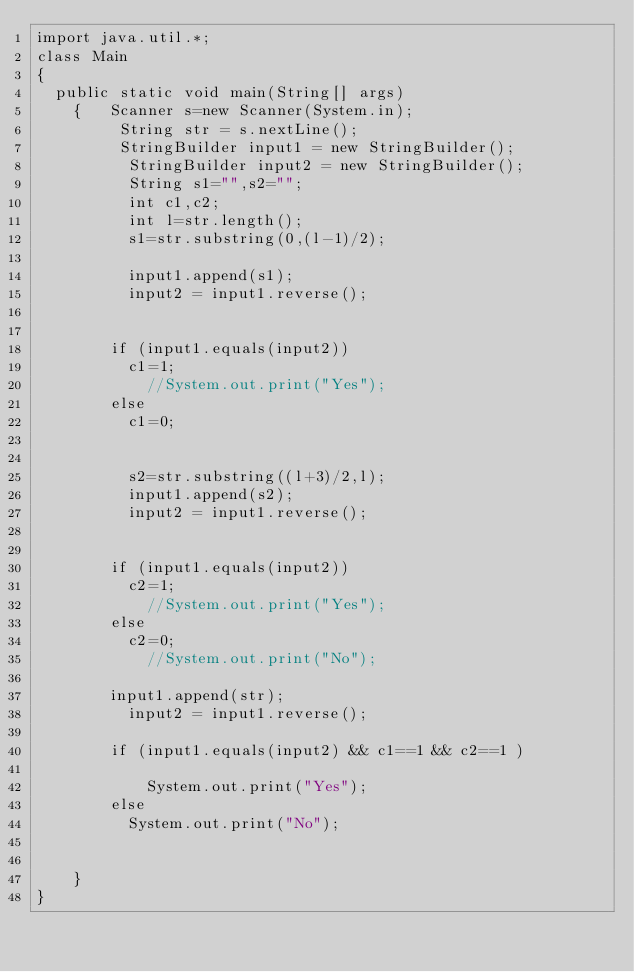Convert code to text. <code><loc_0><loc_0><loc_500><loc_500><_Java_>import java.util.*;
class Main
{
	public static void main(String[] args) 
    { 	Scanner s=new Scanner(System.in);
         String str = s.nextLine(); 
         StringBuilder input1 = new StringBuilder(); 
          StringBuilder input2 = new StringBuilder(); 
          String s1="",s2="";
          int c1,c2;
          int l=str.length();
          s1=str.substring(0,(l-1)/2);
          
          input1.append(s1);
          input2 = input1.reverse();
        
  
        if (input1.equals(input2)) 
        	c1=1;
            //System.out.print("Yes"); 
        else
        	c1=0;
        
       
          s2=str.substring((l+3)/2,l);
          input1.append(s2);
          input2 = input1.reverse();
        
  
        if (input1.equals(input2)) 
        	c2=1;
            //System.out.print("Yes"); 
        else
        	c2=0;
            //System.out.print("No"); 

        input1.append(str);
          input2 = input1.reverse();

        if (input1.equals(input2) && c1==1 && c2==1 ) 
        	
            System.out.print("Yes"); 
        else
        	System.out.print("No"); 

        	
    } 
}
</code> 